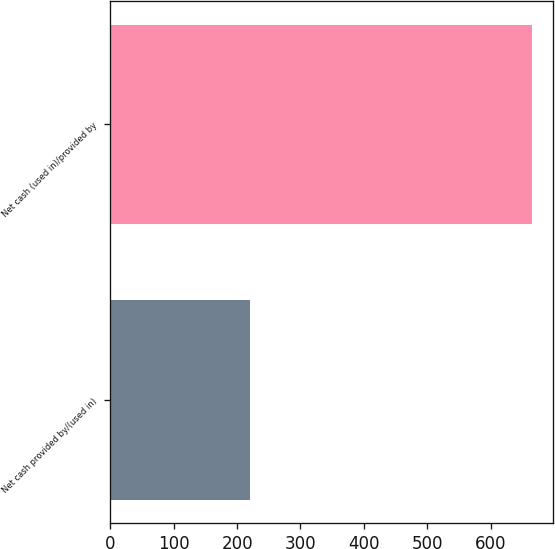<chart> <loc_0><loc_0><loc_500><loc_500><bar_chart><fcel>Net cash provided by/(used in)<fcel>Net cash (used in)/provided by<nl><fcel>219.8<fcel>665.2<nl></chart> 